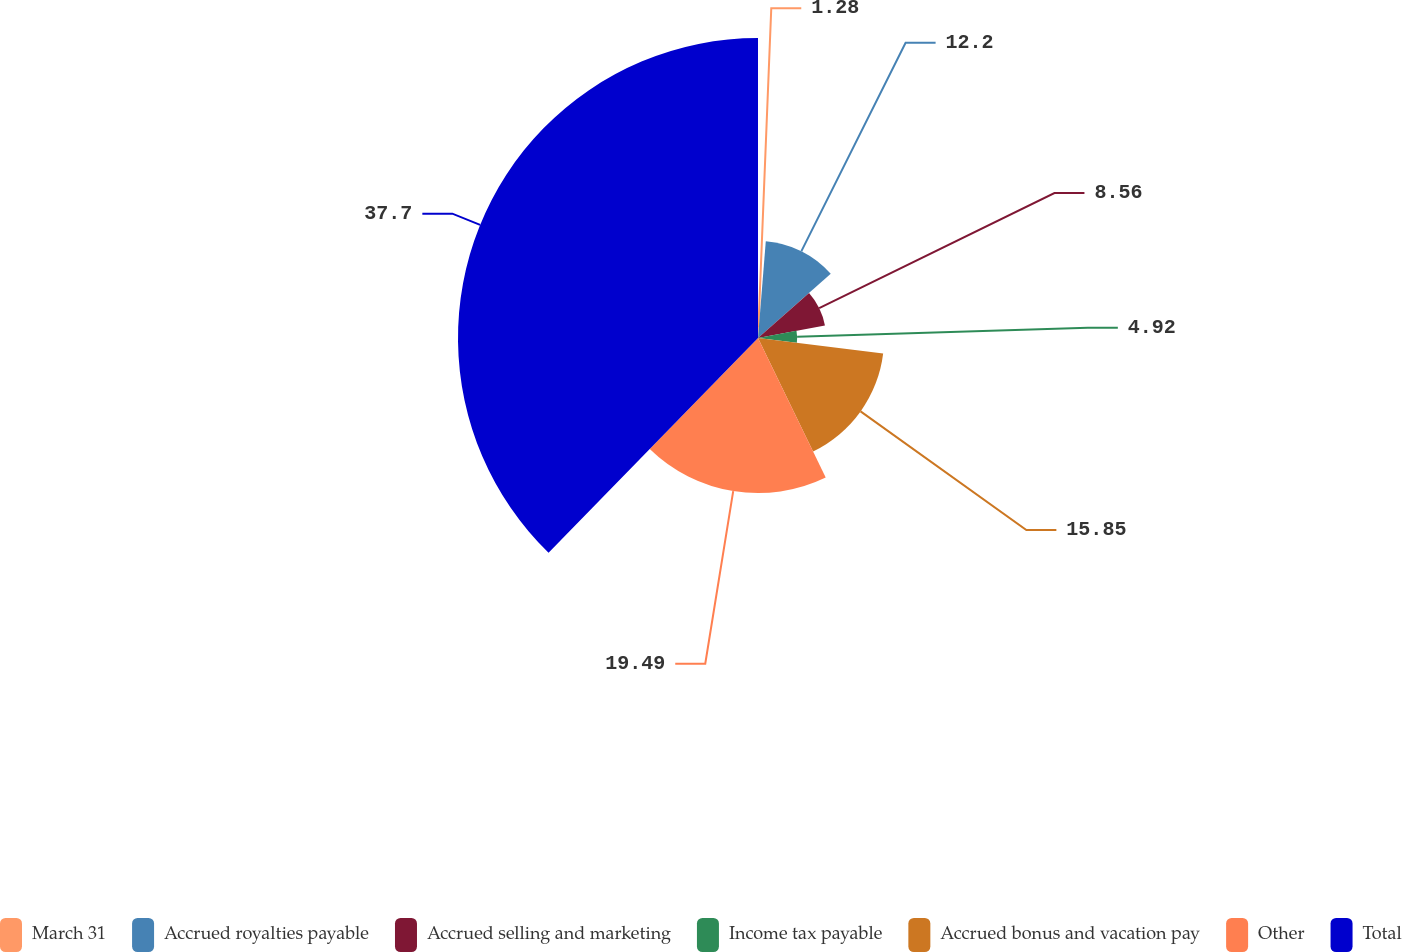Convert chart to OTSL. <chart><loc_0><loc_0><loc_500><loc_500><pie_chart><fcel>March 31<fcel>Accrued royalties payable<fcel>Accrued selling and marketing<fcel>Income tax payable<fcel>Accrued bonus and vacation pay<fcel>Other<fcel>Total<nl><fcel>1.28%<fcel>12.2%<fcel>8.56%<fcel>4.92%<fcel>15.85%<fcel>19.49%<fcel>37.7%<nl></chart> 